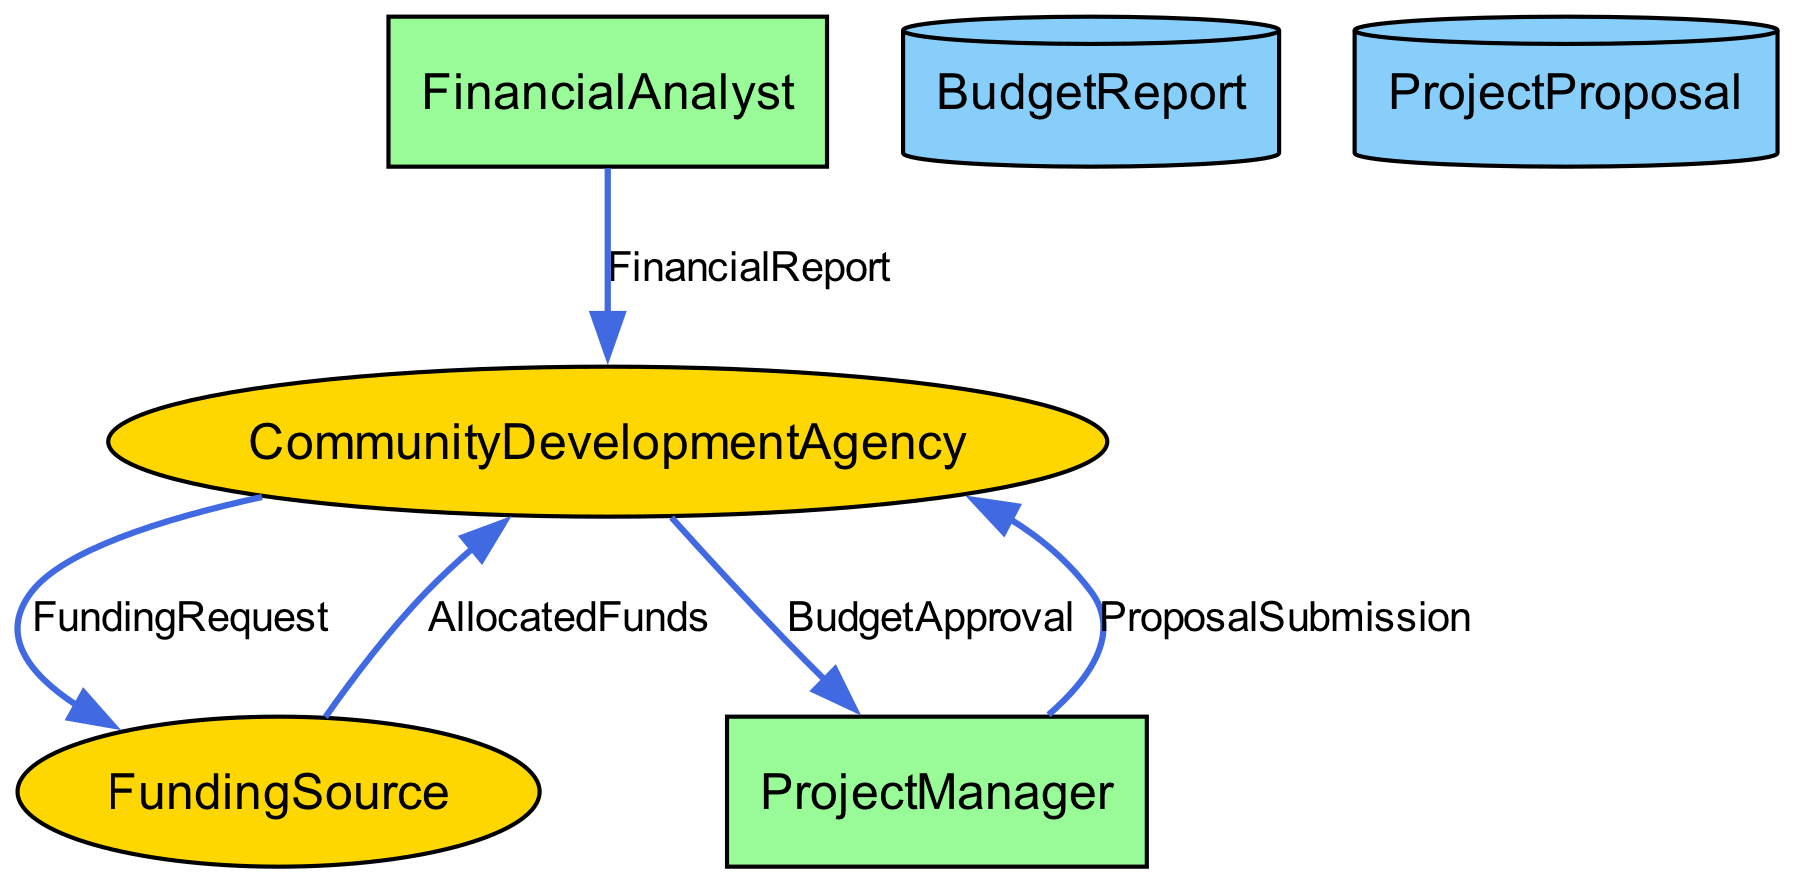What is the main agency responsible for community development projects? The diagram identifies the "CommunityDevelopmentAgency" as the external entity overseeing community development projects.
Answer: CommunityDevelopmentAgency How many processes are present in the diagram? By counting the nodes classified as processes, we see there are two distinct processes: "ProjectManager" and "FinancialAnalyst".
Answer: 2 What type of entity is "BudgetReport"? The "BudgetReport" is categorized as a "DataStore" based on the description in the diagram.
Answer: DataStore Which entity requests funds from the funding sources? The "CommunityDevelopmentAgency" initiates and sends the "FundingRequest" to the "FundingSource".
Answer: CommunityDevelopmentAgency What does the "FinancialReport" detail? The "FinancialReport" provides details on the financial status, resource allocation efficiency, and recommendations for management.
Answer: Financial status, allocation efficiency, recommendations What is the flow direction from "FundingSource" to "CommunityDevelopmentAgency"? The flow is identified as "AllocatedFunds," which indicates a transfer of funds from the funding source to the agency.
Answer: AllocatedFunds Which processes are responsible for submitting proposals to the agency? The "ProjectManager" is responsible for submitting project proposals to the "CommunityDevelopmentAgency" for approval and funding.
Answer: ProjectManager What feedback does the "CommunityDevelopmentAgency" provide to the "ProjectManager"? The agency provides "BudgetApproval," which notifies the project manager whether the budget for a project is approved or rejected.
Answer: BudgetApproval What document outlines proposed community development projects? The "ProjectProposal" serves as the document outlining the details of proposed projects, including costs and benefits.
Answer: ProjectProposal Who analyzes the financial data in the diagram? The "FinancialAnalyst" is responsible for analyzing financial data, creating reports, and ensuring efficient allocation of resources.
Answer: FinancialAnalyst 